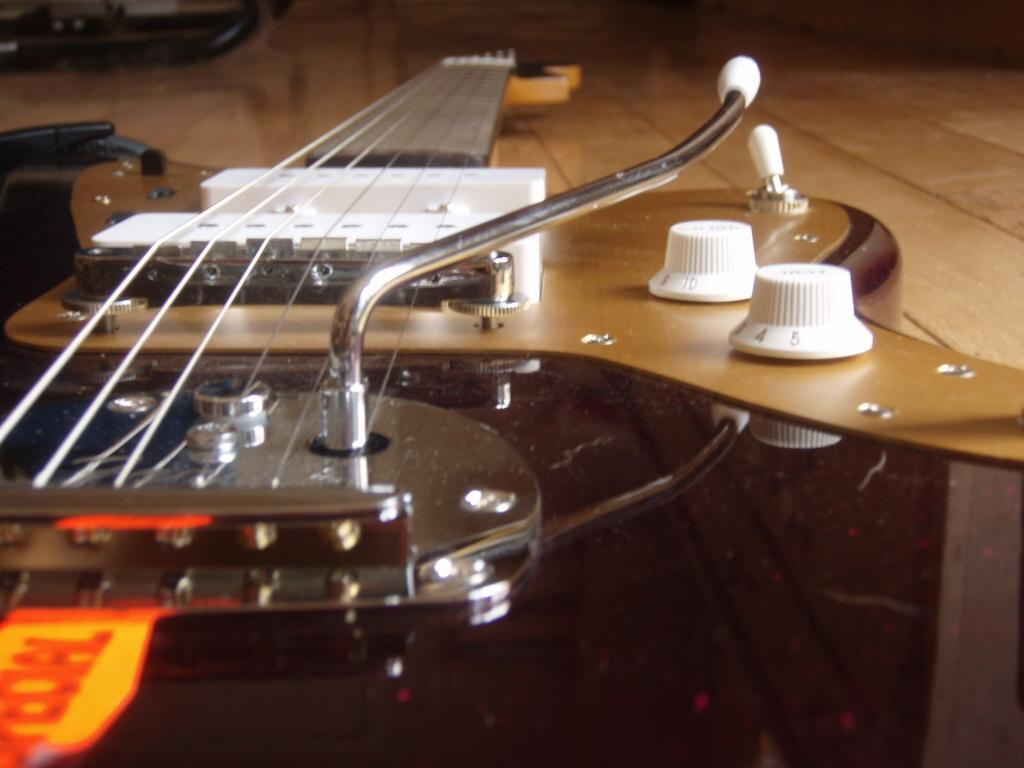What musical instrument is visible in the image? There is a guitar on a wooden surface in the image. Can you describe the surface on which the guitar is placed? The guitar is placed on a wooden surface. What else can be seen in the background of the image? There is an object in the background of the image. What type of metal is the vase made of in the image? There is no vase present in the image, so it is not possible to determine the type of metal it might be made of. 